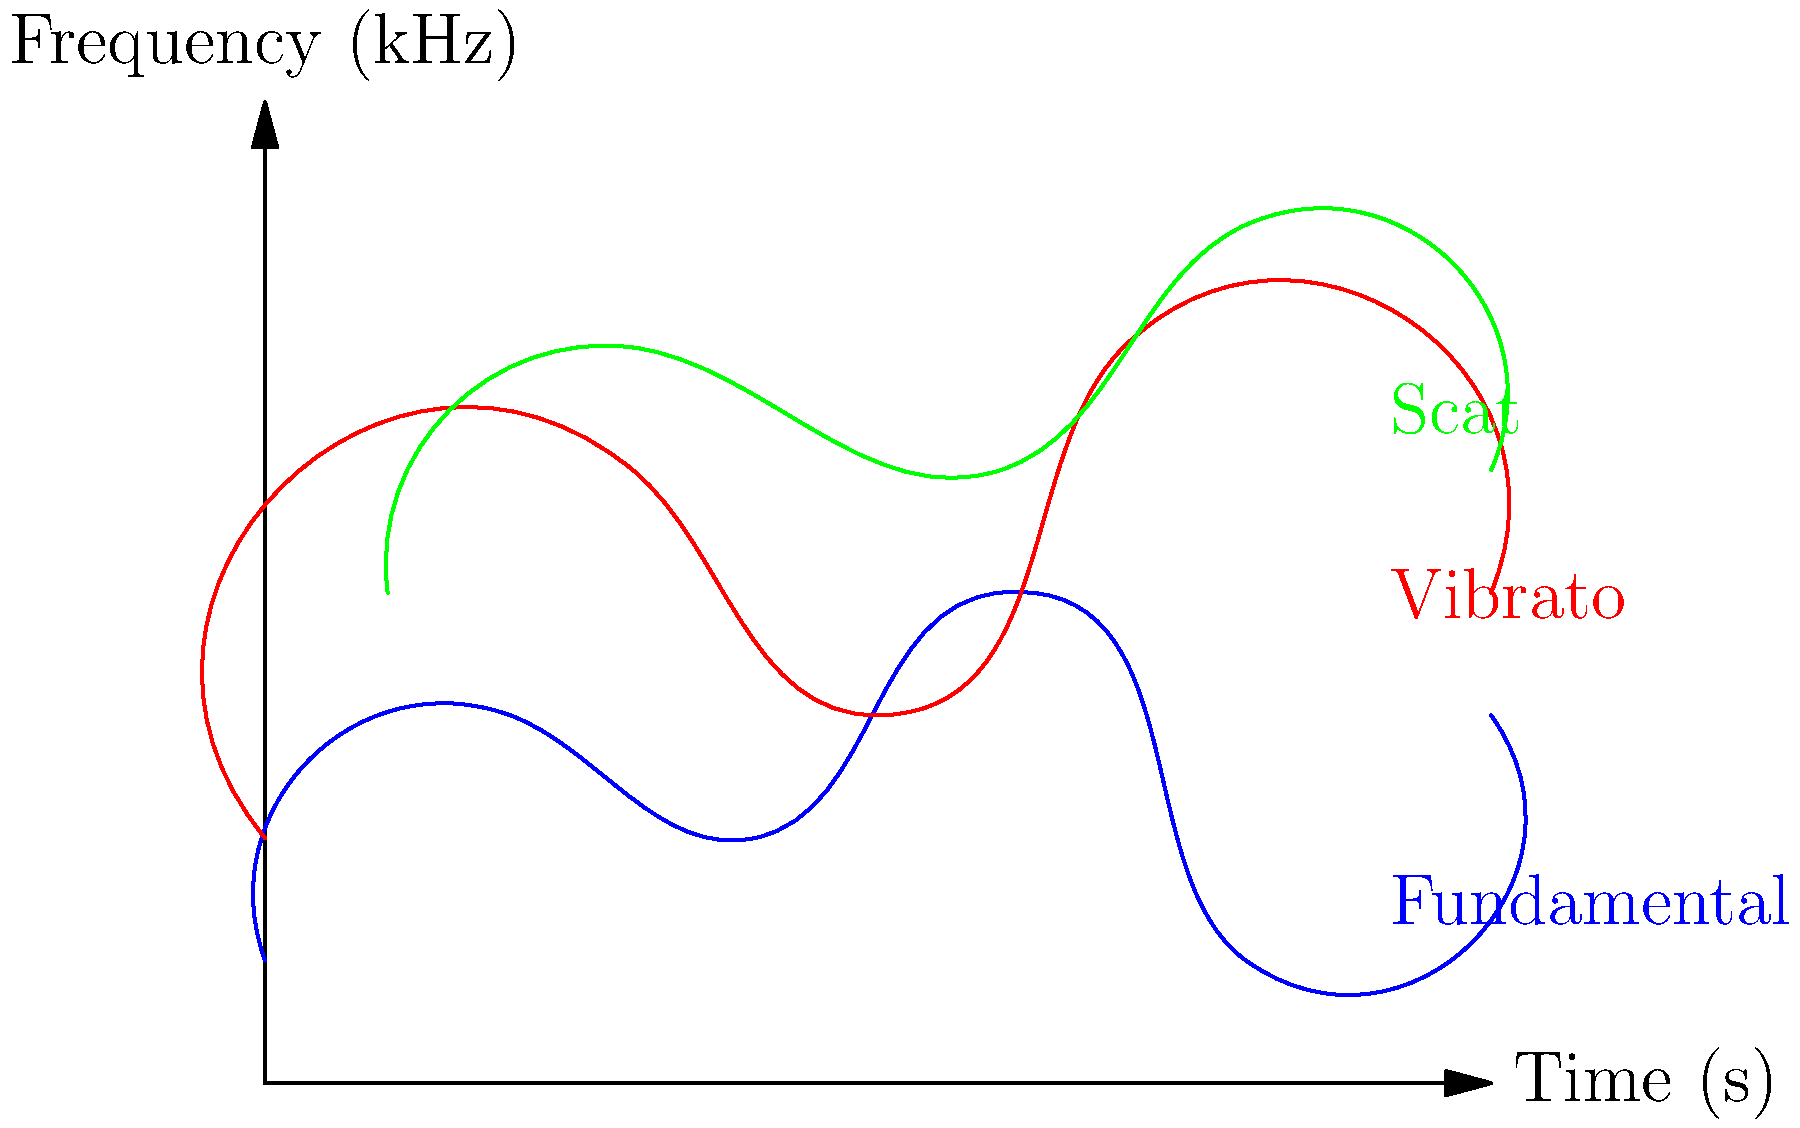Analyze the spectrogram of a female jazz vocalist's performance. Which vocal technique is represented by the red line, demonstrating a wavering pitch over time? To identify the vocal technique represented by the red line in the spectrogram, let's analyze the characteristics of each line:

1. The blue line at the bottom represents the fundamental frequency or the main pitch of the vocalist's voice. It shows the basic melody line.

2. The green line at the top shows rapid pitch changes and irregular patterns, which is characteristic of scat singing, a common improvisation technique in jazz.

3. The red line in the middle exhibits a regular, wave-like pattern that oscillates up and down over time. This wavering pitch is a clear indication of vibrato, a technique where the singer intentionally varies the pitch of a sustained note to add expression and warmth to the voice.

Vibrato is a crucial element in jazz singing, particularly favored by many female jazz vocalists. It adds depth and emotion to sustained notes and is often used to enhance the overall expressiveness of the performance.

The regular, controlled oscillation shown by the red line is a textbook representation of vibrato in a spectrogram, making it the correct answer to this question.
Answer: Vibrato 